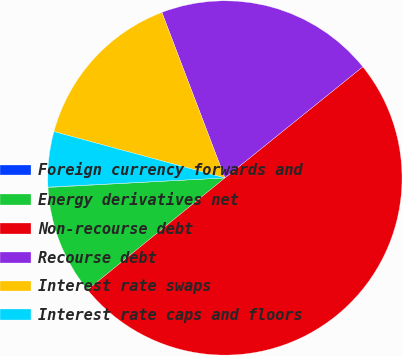<chart> <loc_0><loc_0><loc_500><loc_500><pie_chart><fcel>Foreign currency forwards and<fcel>Energy derivatives net<fcel>Non-recourse debt<fcel>Recourse debt<fcel>Interest rate swaps<fcel>Interest rate caps and floors<nl><fcel>0.04%<fcel>10.02%<fcel>49.92%<fcel>19.99%<fcel>15.0%<fcel>5.03%<nl></chart> 